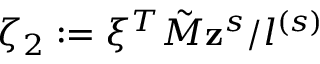Convert formula to latex. <formula><loc_0><loc_0><loc_500><loc_500>\zeta _ { 2 } \colon = \xi ^ { T } \tilde { M } z ^ { s } / l ^ { ( s ) }</formula> 